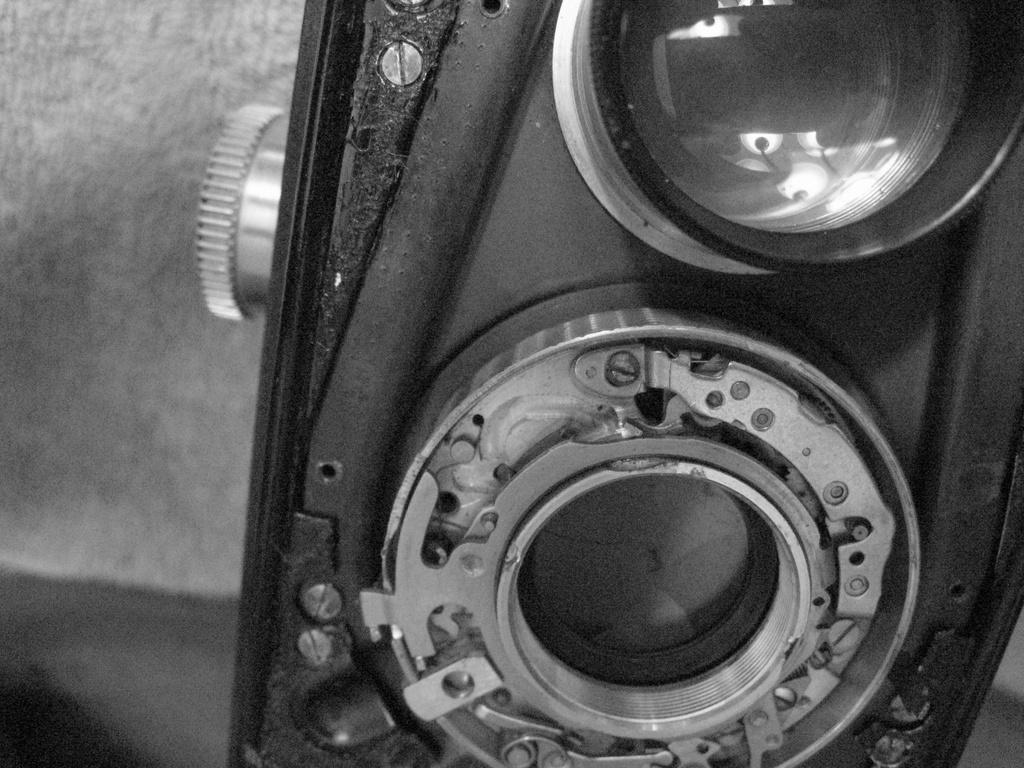What is the color scheme of the image? The image is black and white. What object can be seen in the image? There is an old camera with a lens in the image. How is the left side of the image described? The left side of the image has a blurred view. What type of board is being used by the lawyer in the image? There is no board or lawyer present in the image; it features an old camera with a lens and a blurred view on the left side. 